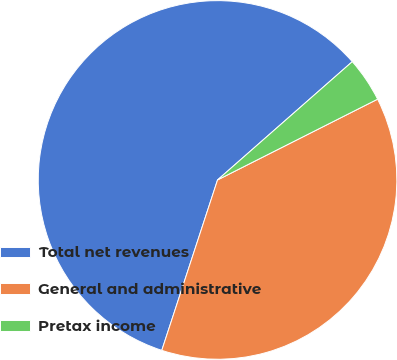Convert chart to OTSL. <chart><loc_0><loc_0><loc_500><loc_500><pie_chart><fcel>Total net revenues<fcel>General and administrative<fcel>Pretax income<nl><fcel>58.5%<fcel>37.47%<fcel>4.03%<nl></chart> 